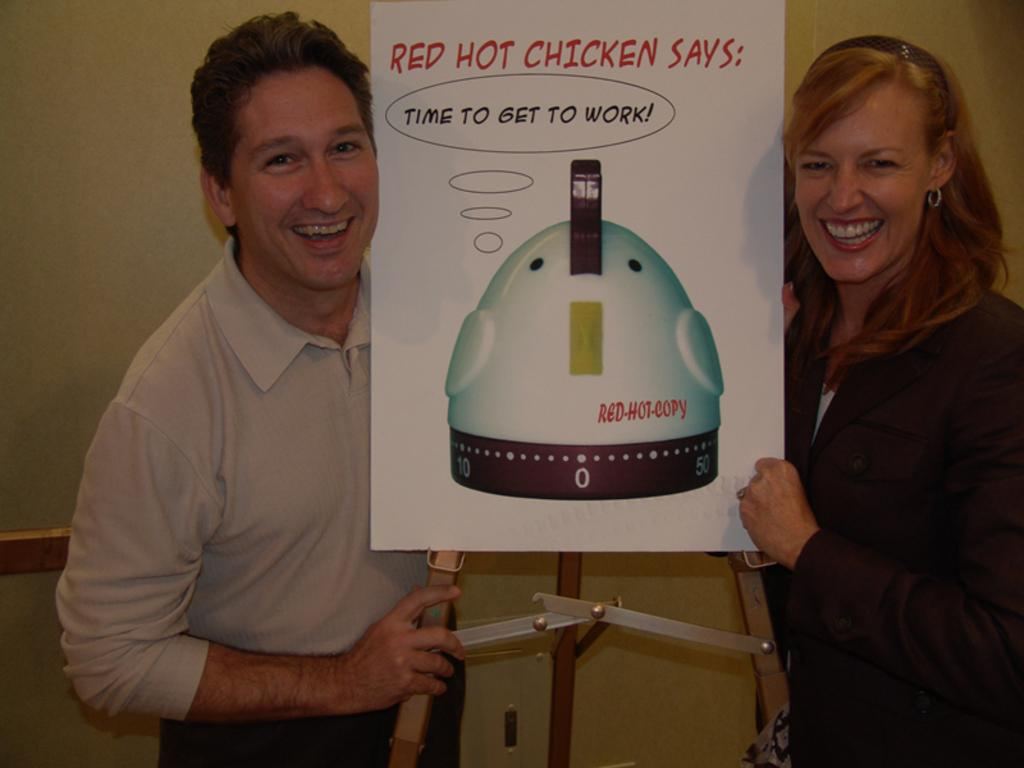How many people are present in the image? There are two people, a man and a woman, present in the image. What are the man and woman holding in the image? The man and woman are holding a poster with a stand. What expressions do the man and woman have in the image? The man and woman are smiling in the image. What can be seen on the poster they are holding? There is an image and something written on the poster. What is visible in the background of the image? There is a wall in the background of the image. What type of arithmetic problem is the man solving with his sister in the image? There is no mention of a sister or an arithmetic problem in the image. Can you see a ghost in the image? There is no ghost present in the image. 